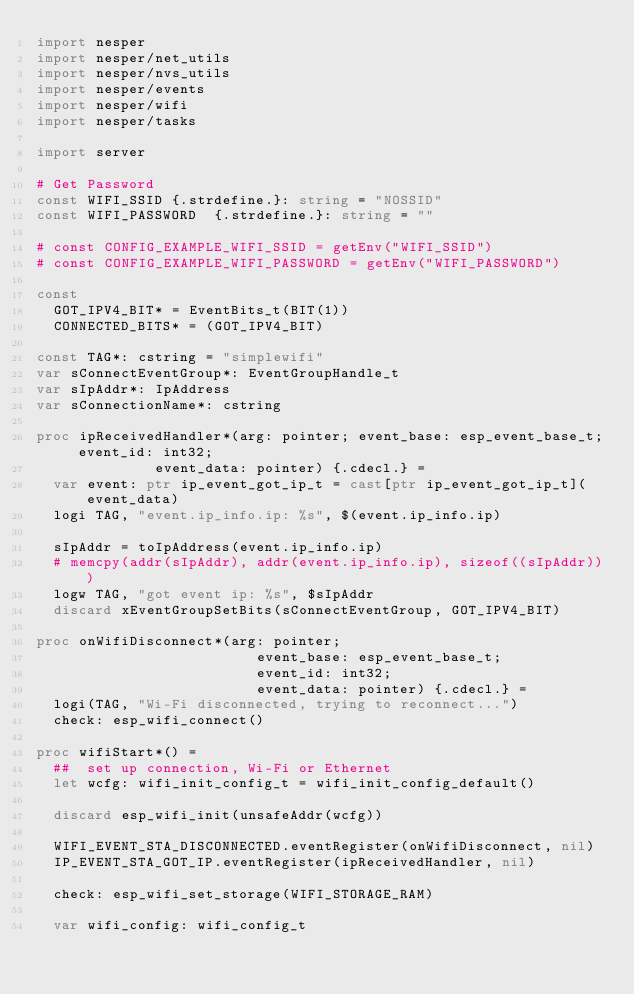Convert code to text. <code><loc_0><loc_0><loc_500><loc_500><_Nim_>import nesper
import nesper/net_utils
import nesper/nvs_utils
import nesper/events
import nesper/wifi
import nesper/tasks

import server

# Get Password
const WIFI_SSID {.strdefine.}: string = "NOSSID"
const WIFI_PASSWORD  {.strdefine.}: string = "" 

# const CONFIG_EXAMPLE_WIFI_SSID = getEnv("WIFI_SSID")
# const CONFIG_EXAMPLE_WIFI_PASSWORD = getEnv("WIFI_PASSWORD")

const
  GOT_IPV4_BIT* = EventBits_t(BIT(1))
  CONNECTED_BITS* = (GOT_IPV4_BIT)

const TAG*: cstring = "simplewifi"
var sConnectEventGroup*: EventGroupHandle_t
var sIpAddr*: IpAddress
var sConnectionName*: cstring

proc ipReceivedHandler*(arg: pointer; event_base: esp_event_base_t; event_id: int32;
              event_data: pointer) {.cdecl.} =
  var event: ptr ip_event_got_ip_t = cast[ptr ip_event_got_ip_t](event_data)
  logi TAG, "event.ip_info.ip: %s", $(event.ip_info.ip)

  sIpAddr = toIpAddress(event.ip_info.ip)
  # memcpy(addr(sIpAddr), addr(event.ip_info.ip), sizeof((sIpAddr)))
  logw TAG, "got event ip: %s", $sIpAddr
  discard xEventGroupSetBits(sConnectEventGroup, GOT_IPV4_BIT)

proc onWifiDisconnect*(arg: pointer;
                          event_base: esp_event_base_t;
                          event_id: int32;
                          event_data: pointer) {.cdecl.} =
  logi(TAG, "Wi-Fi disconnected, trying to reconnect...")
  check: esp_wifi_connect()

proc wifiStart*() =
  ##  set up connection, Wi-Fi or Ethernet
  let wcfg: wifi_init_config_t = wifi_init_config_default()

  discard esp_wifi_init(unsafeAddr(wcfg))

  WIFI_EVENT_STA_DISCONNECTED.eventRegister(onWifiDisconnect, nil)
  IP_EVENT_STA_GOT_IP.eventRegister(ipReceivedHandler, nil)

  check: esp_wifi_set_storage(WIFI_STORAGE_RAM)

  var wifi_config: wifi_config_t</code> 